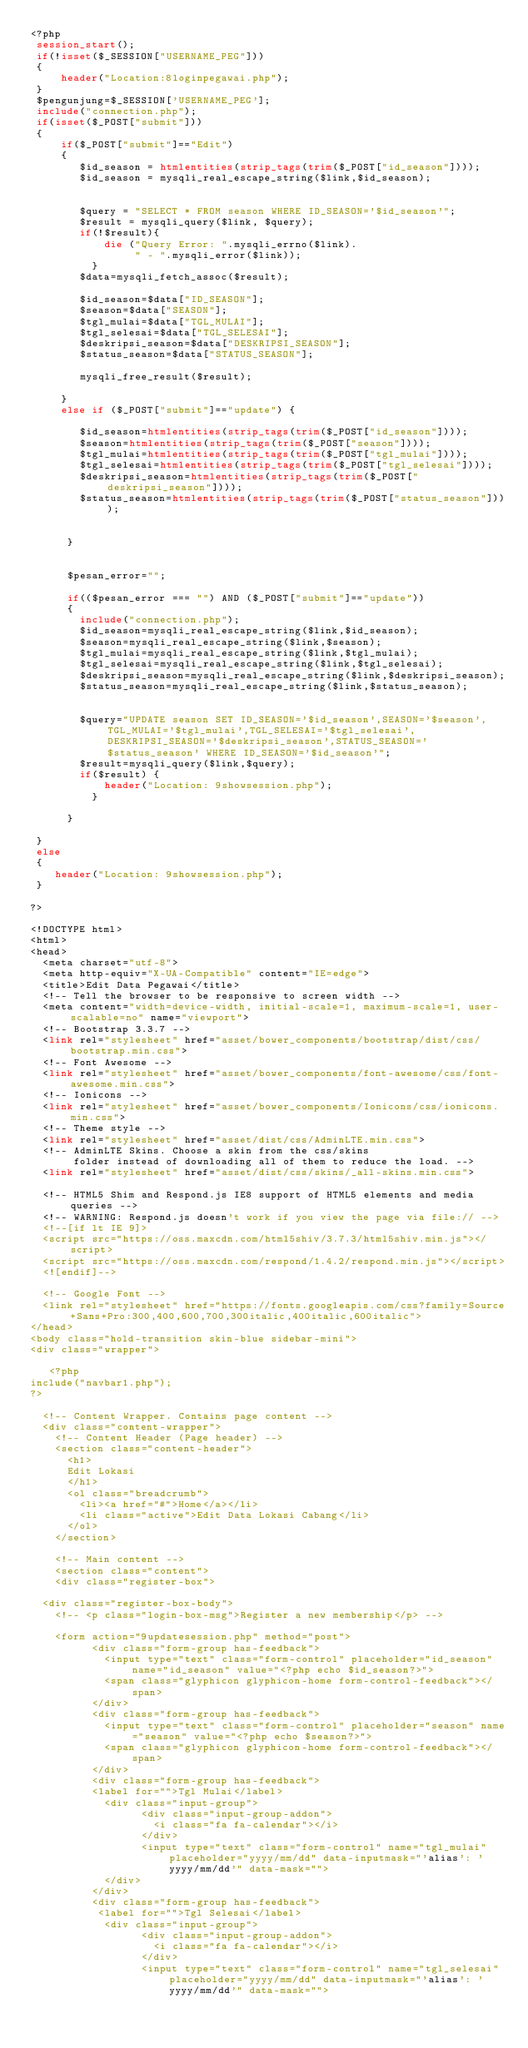Convert code to text. <code><loc_0><loc_0><loc_500><loc_500><_PHP_><?php
 session_start();
 if(!isset($_SESSION["USERNAME_PEG"]))
 {    
     header("Location:8loginpegawai.php");    
 }
 $pengunjung=$_SESSION['USERNAME_PEG'];
 include("connection.php");
 if(isset($_POST["submit"]))
 {
     if($_POST["submit"]=="Edit")
     {
        $id_season = htmlentities(strip_tags(trim($_POST["id_season"])));
        $id_season = mysqli_real_escape_string($link,$id_season);
    
        
        $query = "SELECT * FROM season WHERE ID_SEASON='$id_season'";
        $result = mysqli_query($link, $query);
        if(!$result){
            die ("Query Error: ".mysqli_errno($link).
                 " - ".mysqli_error($link));
          }
        $data=mysqli_fetch_assoc($result);

        $id_season=$data["ID_SEASON"];
        $season=$data["SEASON"];
        $tgl_mulai=$data["TGL_MULAI"];
        $tgl_selesai=$data["TGL_SELESAI"];
        $deskripsi_season=$data["DESKRIPSI_SEASON"];
        $status_season=$data["STATUS_SEASON"];
       
        mysqli_free_result($result);
       
     }
     else if ($_POST["submit"]=="update") {
        
        $id_season=htmlentities(strip_tags(trim($_POST["id_season"])));
        $season=htmlentities(strip_tags(trim($_POST["season"])));
        $tgl_mulai=htmlentities(strip_tags(trim($_POST["tgl_mulai"])));
        $tgl_selesai=htmlentities(strip_tags(trim($_POST["tgl_selesai"])));
        $deskripsi_season=htmlentities(strip_tags(trim($_POST["deskripsi_season"])));
        $status_season=htmlentities(strip_tags(trim($_POST["status_season"])));    
       
      
      }
  
      
      $pesan_error="";     
      
      if(($pesan_error === "") AND ($_POST["submit"]=="update"))
      {    
        include("connection.php");       
        $id_season=mysqli_real_escape_string($link,$id_season);
        $season=mysqli_real_escape_string($link,$season);
        $tgl_mulai=mysqli_real_escape_string($link,$tgl_mulai);
        $tgl_selesai=mysqli_real_escape_string($link,$tgl_selesai);
        $deskripsi_season=mysqli_real_escape_string($link,$deskripsi_season);
        $status_season=mysqli_real_escape_string($link,$status_season);
                  
                  
        $query="UPDATE season SET ID_SEASON='$id_season',SEASON='$season',TGL_MULAI='$tgl_mulai',TGL_SELESAI='$tgl_selesai',DESKRIPSI_SEASON='$deskripsi_season',STATUS_SEASON='$status_season' WHERE ID_SEASON='$id_season'";
        $result=mysqli_query($link,$query);
        if($result) {                   
            header("Location: 9showsession.php");
          } 
     
      }
      
 }
 else
 {
    header("Location: 9showsession.php");
 }

?>

<!DOCTYPE html>
<html>
<head>
  <meta charset="utf-8">
  <meta http-equiv="X-UA-Compatible" content="IE=edge">
  <title>Edit Data Pegawai</title>
  <!-- Tell the browser to be responsive to screen width -->
  <meta content="width=device-width, initial-scale=1, maximum-scale=1, user-scalable=no" name="viewport">
  <!-- Bootstrap 3.3.7 -->
  <link rel="stylesheet" href="asset/bower_components/bootstrap/dist/css/bootstrap.min.css">
  <!-- Font Awesome -->
  <link rel="stylesheet" href="asset/bower_components/font-awesome/css/font-awesome.min.css">
  <!-- Ionicons -->
  <link rel="stylesheet" href="asset/bower_components/Ionicons/css/ionicons.min.css">
  <!-- Theme style -->
  <link rel="stylesheet" href="asset/dist/css/AdminLTE.min.css">
  <!-- AdminLTE Skins. Choose a skin from the css/skins
       folder instead of downloading all of them to reduce the load. -->
  <link rel="stylesheet" href="asset/dist/css/skins/_all-skins.min.css">

  <!-- HTML5 Shim and Respond.js IE8 support of HTML5 elements and media queries -->
  <!-- WARNING: Respond.js doesn't work if you view the page via file:// -->
  <!--[if lt IE 9]>
  <script src="https://oss.maxcdn.com/html5shiv/3.7.3/html5shiv.min.js"></script>
  <script src="https://oss.maxcdn.com/respond/1.4.2/respond.min.js"></script>
  <![endif]-->

  <!-- Google Font -->
  <link rel="stylesheet" href="https://fonts.googleapis.com/css?family=Source+Sans+Pro:300,400,600,700,300italic,400italic,600italic">
</head>
<body class="hold-transition skin-blue sidebar-mini">
<div class="wrapper">

   <?php
include("navbar1.php");
?>

  <!-- Content Wrapper. Contains page content -->
  <div class="content-wrapper">
    <!-- Content Header (Page header) -->
    <section class="content-header">
      <h1>
      Edit Lokasi
      </h1>
      <ol class="breadcrumb">        
        <li><a href="#">Home</a></li>
        <li class="active">Edit Data Lokasi Cabang</li>
      </ol>
    </section>

    <!-- Main content -->
    <section class="content">
    <div class="register-box">  

  <div class="register-box-body">
    <!-- <p class="login-box-msg">Register a new membership</p> -->

    <form action="9updatesession.php" method="post">
          <div class="form-group has-feedback">
            <input type="text" class="form-control" placeholder="id_season" name="id_season" value="<?php echo $id_season?>">
            <span class="glyphicon glyphicon-home form-control-feedback"></span>
          </div>
          <div class="form-group has-feedback">
            <input type="text" class="form-control" placeholder="season" name="season" value="<?php echo $season?>">
            <span class="glyphicon glyphicon-home form-control-feedback"></span>
          </div>
          <div class="form-group has-feedback">  
          <label for="">Tgl Mulai</label>         
            <div class="input-group">
                  <div class="input-group-addon">
                    <i class="fa fa-calendar"></i>
                  </div>
                  <input type="text" class="form-control" name="tgl_mulai" placeholder="yyyy/mm/dd" data-inputmask="'alias': 'yyyy/mm/dd'" data-mask="">
            </div>
          </div>          
          <div class="form-group has-feedback">
           <label for="">Tgl Selesai</label>
            <div class="input-group">
                  <div class="input-group-addon">
                    <i class="fa fa-calendar"></i>
                  </div>
                  <input type="text" class="form-control" name="tgl_selesai" placeholder="yyyy/mm/dd" data-inputmask="'alias': 'yyyy/mm/dd'" data-mask=""></code> 